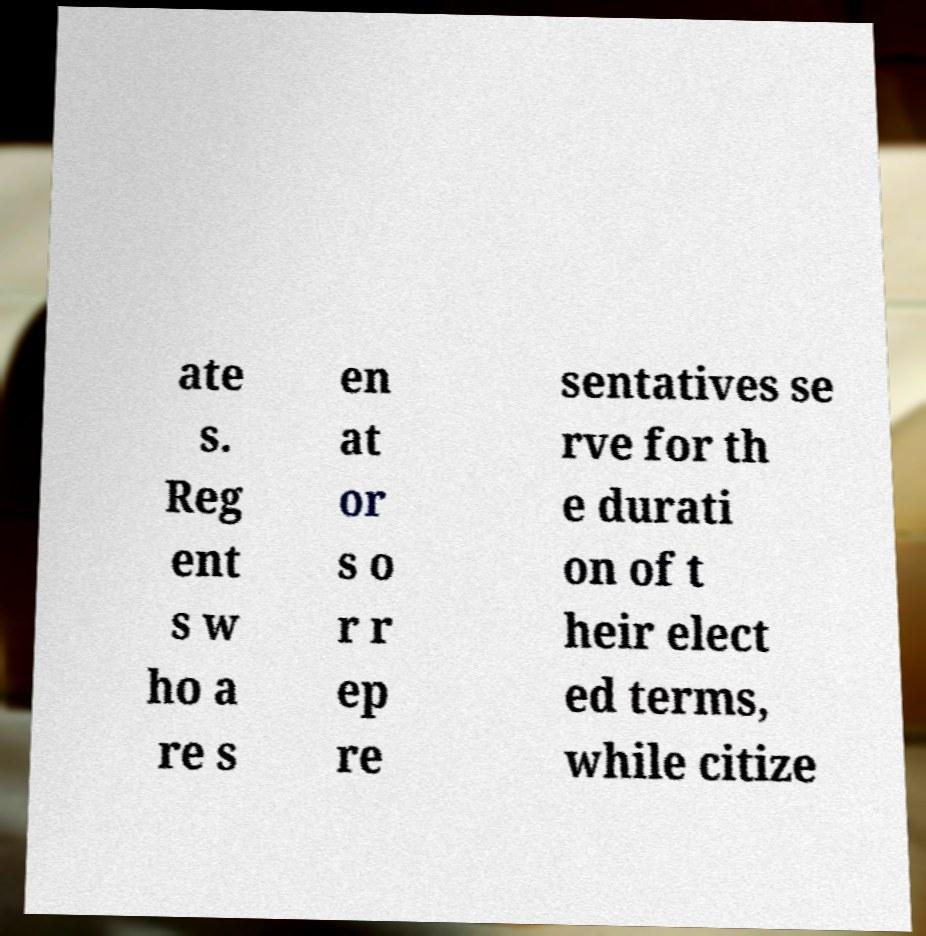There's text embedded in this image that I need extracted. Can you transcribe it verbatim? ate s. Reg ent s w ho a re s en at or s o r r ep re sentatives se rve for th e durati on of t heir elect ed terms, while citize 